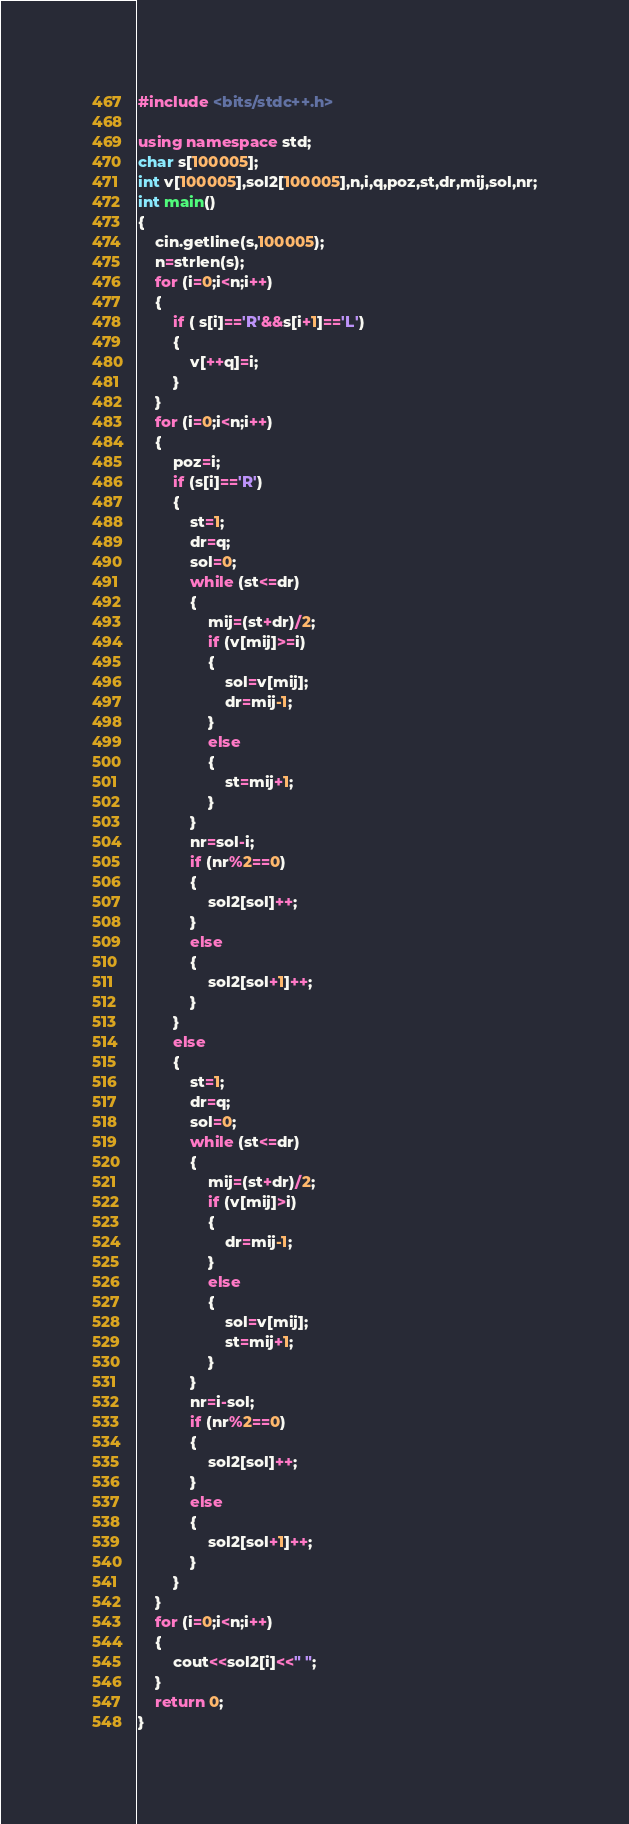<code> <loc_0><loc_0><loc_500><loc_500><_C++_>#include <bits/stdc++.h>

using namespace std;
char s[100005];
int v[100005],sol2[100005],n,i,q,poz,st,dr,mij,sol,nr;
int main()
{
    cin.getline(s,100005);
    n=strlen(s);
    for (i=0;i<n;i++)
    {
        if ( s[i]=='R'&&s[i+1]=='L')
        {
            v[++q]=i;
        }
    }
    for (i=0;i<n;i++)
    {
        poz=i;
        if (s[i]=='R')
        {
            st=1;
            dr=q;
            sol=0;
            while (st<=dr)
            {
                mij=(st+dr)/2;
                if (v[mij]>=i)
                {
                    sol=v[mij];
                    dr=mij-1;
                }
                else
                {
                    st=mij+1;
                }
            }
            nr=sol-i;
            if (nr%2==0)
            {
                sol2[sol]++;
            }
            else
            {
                sol2[sol+1]++;
            }
        }
        else
        {
            st=1;
            dr=q;
            sol=0;
            while (st<=dr)
            {
                mij=(st+dr)/2;
                if (v[mij]>i)
                {
                    dr=mij-1;
                }
                else
                {
                    sol=v[mij];
                    st=mij+1;
                }
            }
            nr=i-sol;
            if (nr%2==0)
            {
                sol2[sol]++;
            }
            else
            {
                sol2[sol+1]++;
            }
        }
    }
    for (i=0;i<n;i++)
    {
        cout<<sol2[i]<<" ";
    }
    return 0;
}
</code> 